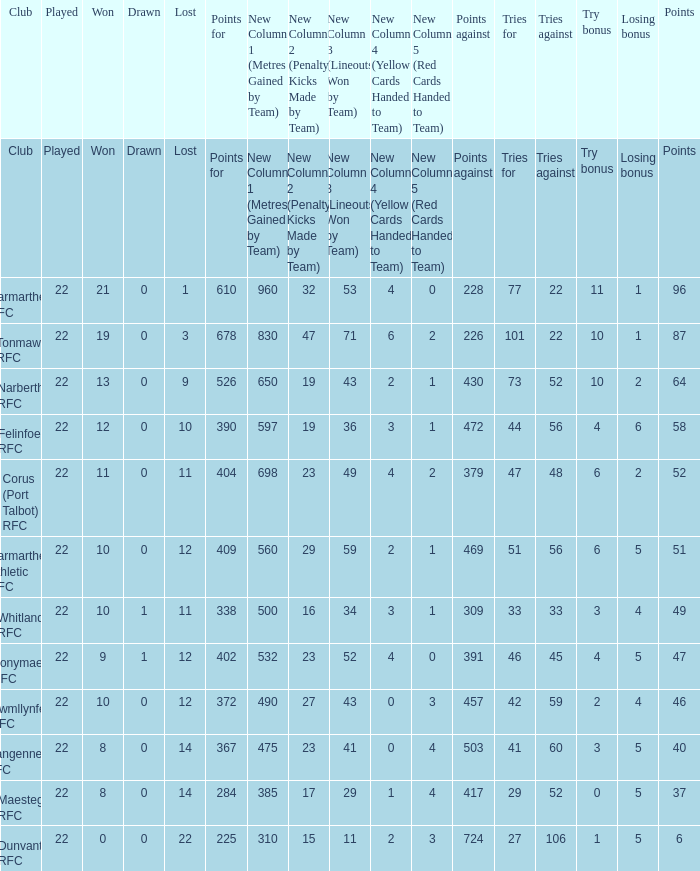Name the tries against for drawn 1.0. 